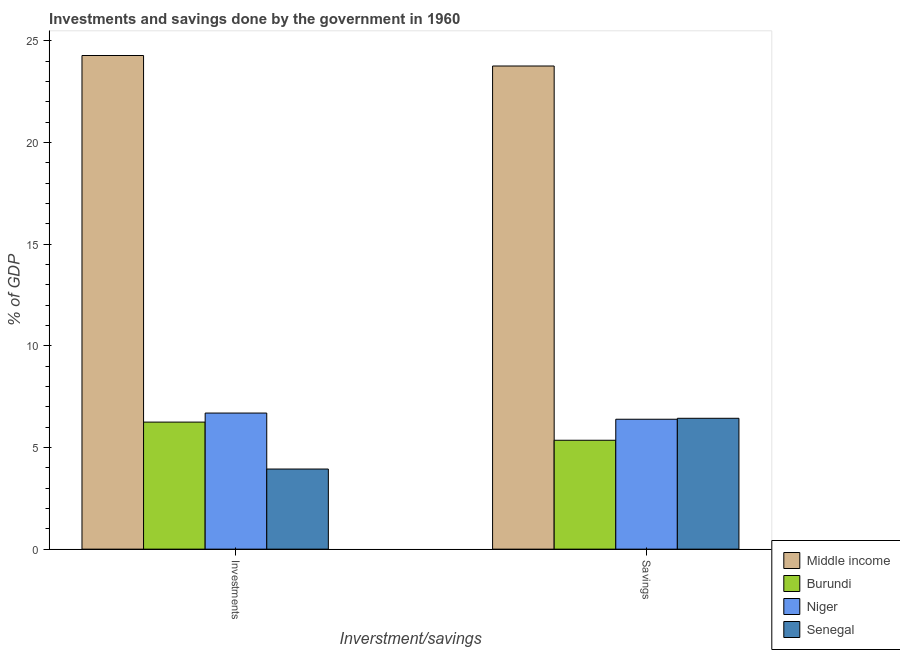How many different coloured bars are there?
Keep it short and to the point. 4. How many groups of bars are there?
Provide a short and direct response. 2. How many bars are there on the 1st tick from the left?
Provide a short and direct response. 4. How many bars are there on the 1st tick from the right?
Your response must be concise. 4. What is the label of the 1st group of bars from the left?
Your answer should be compact. Investments. What is the investments of government in Burundi?
Give a very brief answer. 6.25. Across all countries, what is the maximum investments of government?
Give a very brief answer. 24.28. Across all countries, what is the minimum savings of government?
Make the answer very short. 5.36. In which country was the investments of government maximum?
Your response must be concise. Middle income. In which country was the investments of government minimum?
Your answer should be compact. Senegal. What is the total savings of government in the graph?
Your answer should be compact. 41.95. What is the difference between the savings of government in Niger and that in Burundi?
Your answer should be compact. 1.03. What is the difference between the savings of government in Niger and the investments of government in Middle income?
Offer a terse response. -17.89. What is the average investments of government per country?
Offer a very short reply. 10.29. What is the difference between the savings of government and investments of government in Middle income?
Offer a very short reply. -0.52. In how many countries, is the investments of government greater than 10 %?
Ensure brevity in your answer.  1. What is the ratio of the investments of government in Middle income to that in Senegal?
Keep it short and to the point. 6.16. Is the investments of government in Burundi less than that in Niger?
Offer a terse response. Yes. In how many countries, is the investments of government greater than the average investments of government taken over all countries?
Ensure brevity in your answer.  1. What does the 3rd bar from the left in Investments represents?
Give a very brief answer. Niger. What does the 1st bar from the right in Investments represents?
Provide a short and direct response. Senegal. How many bars are there?
Keep it short and to the point. 8. Does the graph contain grids?
Offer a terse response. No. Where does the legend appear in the graph?
Provide a short and direct response. Bottom right. How are the legend labels stacked?
Provide a succinct answer. Vertical. What is the title of the graph?
Ensure brevity in your answer.  Investments and savings done by the government in 1960. Does "Armenia" appear as one of the legend labels in the graph?
Your answer should be very brief. No. What is the label or title of the X-axis?
Offer a very short reply. Inverstment/savings. What is the label or title of the Y-axis?
Offer a terse response. % of GDP. What is the % of GDP in Middle income in Investments?
Provide a succinct answer. 24.28. What is the % of GDP in Burundi in Investments?
Your answer should be compact. 6.25. What is the % of GDP in Niger in Investments?
Your answer should be very brief. 6.7. What is the % of GDP in Senegal in Investments?
Offer a very short reply. 3.94. What is the % of GDP of Middle income in Savings?
Offer a very short reply. 23.77. What is the % of GDP of Burundi in Savings?
Provide a short and direct response. 5.36. What is the % of GDP of Niger in Savings?
Make the answer very short. 6.39. What is the % of GDP in Senegal in Savings?
Offer a terse response. 6.44. Across all Inverstment/savings, what is the maximum % of GDP of Middle income?
Offer a very short reply. 24.28. Across all Inverstment/savings, what is the maximum % of GDP of Burundi?
Offer a terse response. 6.25. Across all Inverstment/savings, what is the maximum % of GDP of Niger?
Offer a terse response. 6.7. Across all Inverstment/savings, what is the maximum % of GDP in Senegal?
Offer a very short reply. 6.44. Across all Inverstment/savings, what is the minimum % of GDP in Middle income?
Keep it short and to the point. 23.77. Across all Inverstment/savings, what is the minimum % of GDP in Burundi?
Keep it short and to the point. 5.36. Across all Inverstment/savings, what is the minimum % of GDP of Niger?
Keep it short and to the point. 6.39. Across all Inverstment/savings, what is the minimum % of GDP in Senegal?
Provide a short and direct response. 3.94. What is the total % of GDP of Middle income in the graph?
Make the answer very short. 48.05. What is the total % of GDP in Burundi in the graph?
Your response must be concise. 11.61. What is the total % of GDP in Niger in the graph?
Your answer should be very brief. 13.09. What is the total % of GDP in Senegal in the graph?
Keep it short and to the point. 10.38. What is the difference between the % of GDP of Middle income in Investments and that in Savings?
Provide a short and direct response. 0.52. What is the difference between the % of GDP of Burundi in Investments and that in Savings?
Your response must be concise. 0.89. What is the difference between the % of GDP of Niger in Investments and that in Savings?
Your answer should be compact. 0.3. What is the difference between the % of GDP of Senegal in Investments and that in Savings?
Make the answer very short. -2.5. What is the difference between the % of GDP of Middle income in Investments and the % of GDP of Burundi in Savings?
Give a very brief answer. 18.93. What is the difference between the % of GDP of Middle income in Investments and the % of GDP of Niger in Savings?
Make the answer very short. 17.89. What is the difference between the % of GDP of Middle income in Investments and the % of GDP of Senegal in Savings?
Offer a very short reply. 17.85. What is the difference between the % of GDP in Burundi in Investments and the % of GDP in Niger in Savings?
Ensure brevity in your answer.  -0.14. What is the difference between the % of GDP of Burundi in Investments and the % of GDP of Senegal in Savings?
Offer a very short reply. -0.19. What is the difference between the % of GDP of Niger in Investments and the % of GDP of Senegal in Savings?
Your answer should be very brief. 0.26. What is the average % of GDP in Middle income per Inverstment/savings?
Give a very brief answer. 24.03. What is the average % of GDP of Burundi per Inverstment/savings?
Offer a very short reply. 5.8. What is the average % of GDP of Niger per Inverstment/savings?
Provide a succinct answer. 6.54. What is the average % of GDP of Senegal per Inverstment/savings?
Your answer should be very brief. 5.19. What is the difference between the % of GDP in Middle income and % of GDP in Burundi in Investments?
Ensure brevity in your answer.  18.03. What is the difference between the % of GDP of Middle income and % of GDP of Niger in Investments?
Provide a short and direct response. 17.59. What is the difference between the % of GDP of Middle income and % of GDP of Senegal in Investments?
Make the answer very short. 20.34. What is the difference between the % of GDP of Burundi and % of GDP of Niger in Investments?
Provide a succinct answer. -0.45. What is the difference between the % of GDP in Burundi and % of GDP in Senegal in Investments?
Keep it short and to the point. 2.31. What is the difference between the % of GDP of Niger and % of GDP of Senegal in Investments?
Provide a short and direct response. 2.75. What is the difference between the % of GDP of Middle income and % of GDP of Burundi in Savings?
Offer a terse response. 18.41. What is the difference between the % of GDP in Middle income and % of GDP in Niger in Savings?
Ensure brevity in your answer.  17.38. What is the difference between the % of GDP of Middle income and % of GDP of Senegal in Savings?
Ensure brevity in your answer.  17.33. What is the difference between the % of GDP in Burundi and % of GDP in Niger in Savings?
Your answer should be compact. -1.03. What is the difference between the % of GDP in Burundi and % of GDP in Senegal in Savings?
Keep it short and to the point. -1.08. What is the difference between the % of GDP of Niger and % of GDP of Senegal in Savings?
Offer a terse response. -0.05. What is the ratio of the % of GDP in Middle income in Investments to that in Savings?
Offer a very short reply. 1.02. What is the ratio of the % of GDP in Burundi in Investments to that in Savings?
Give a very brief answer. 1.17. What is the ratio of the % of GDP in Niger in Investments to that in Savings?
Your answer should be compact. 1.05. What is the ratio of the % of GDP of Senegal in Investments to that in Savings?
Provide a short and direct response. 0.61. What is the difference between the highest and the second highest % of GDP in Middle income?
Offer a terse response. 0.52. What is the difference between the highest and the second highest % of GDP in Burundi?
Your answer should be compact. 0.89. What is the difference between the highest and the second highest % of GDP of Niger?
Provide a short and direct response. 0.3. What is the difference between the highest and the second highest % of GDP of Senegal?
Your answer should be compact. 2.5. What is the difference between the highest and the lowest % of GDP of Middle income?
Offer a terse response. 0.52. What is the difference between the highest and the lowest % of GDP of Burundi?
Ensure brevity in your answer.  0.89. What is the difference between the highest and the lowest % of GDP of Niger?
Give a very brief answer. 0.3. What is the difference between the highest and the lowest % of GDP of Senegal?
Keep it short and to the point. 2.5. 